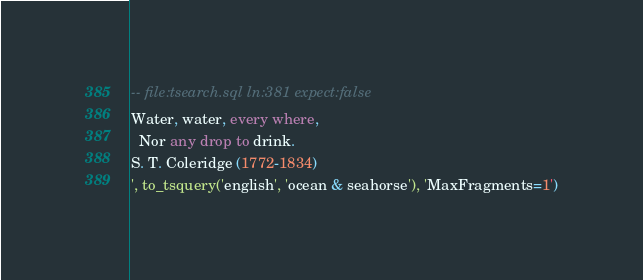Convert code to text. <code><loc_0><loc_0><loc_500><loc_500><_SQL_>-- file:tsearch.sql ln:381 expect:false
Water, water, every where,
  Nor any drop to drink.
S. T. Coleridge (1772-1834)
', to_tsquery('english', 'ocean & seahorse'), 'MaxFragments=1')
</code> 